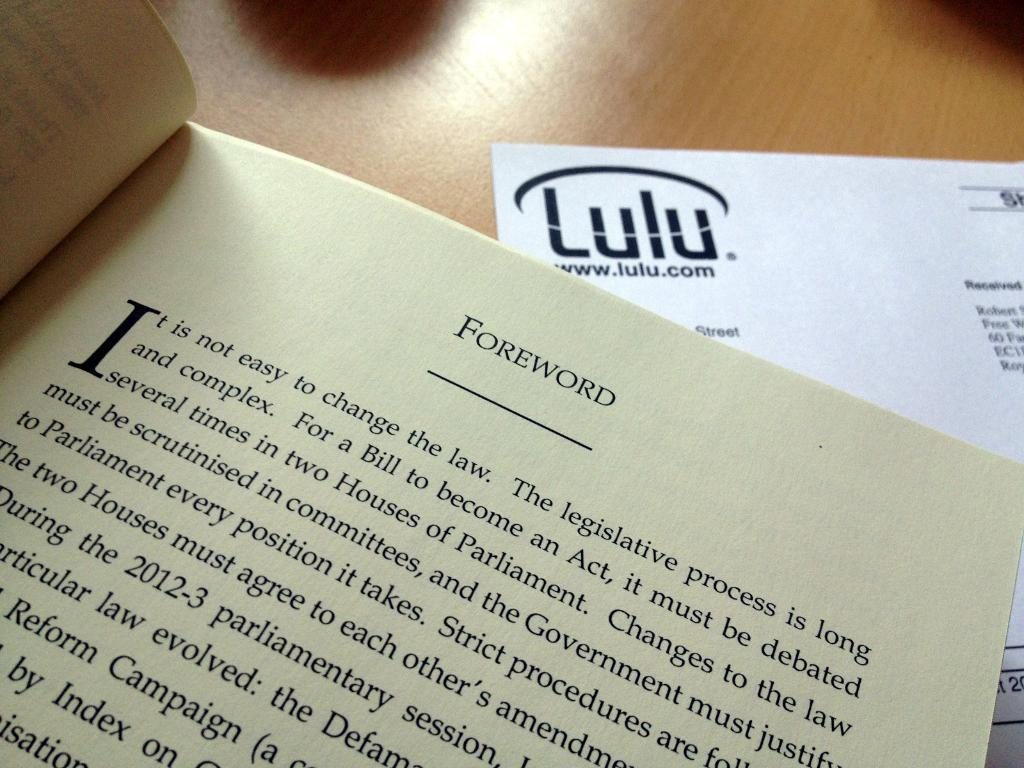<image>
Provide a brief description of the given image. A book about government legislation is open to the forward page. 